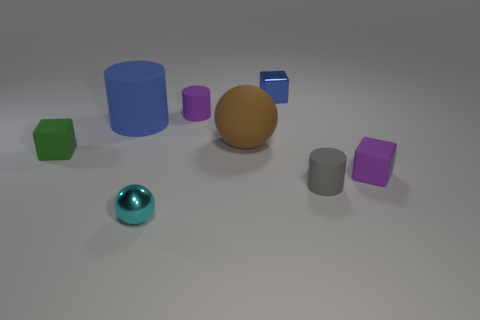Subtract all rubber blocks. How many blocks are left? 1 Add 1 green matte things. How many objects exist? 9 Subtract all green blocks. How many blocks are left? 2 Subtract all cylinders. How many objects are left? 5 Subtract 1 cubes. How many cubes are left? 2 Subtract all yellow balls. Subtract all cyan blocks. How many balls are left? 2 Subtract all red cubes. How many gray cylinders are left? 1 Subtract all small purple rubber cylinders. Subtract all tiny cyan shiny spheres. How many objects are left? 6 Add 5 small blue objects. How many small blue objects are left? 6 Add 7 purple cylinders. How many purple cylinders exist? 8 